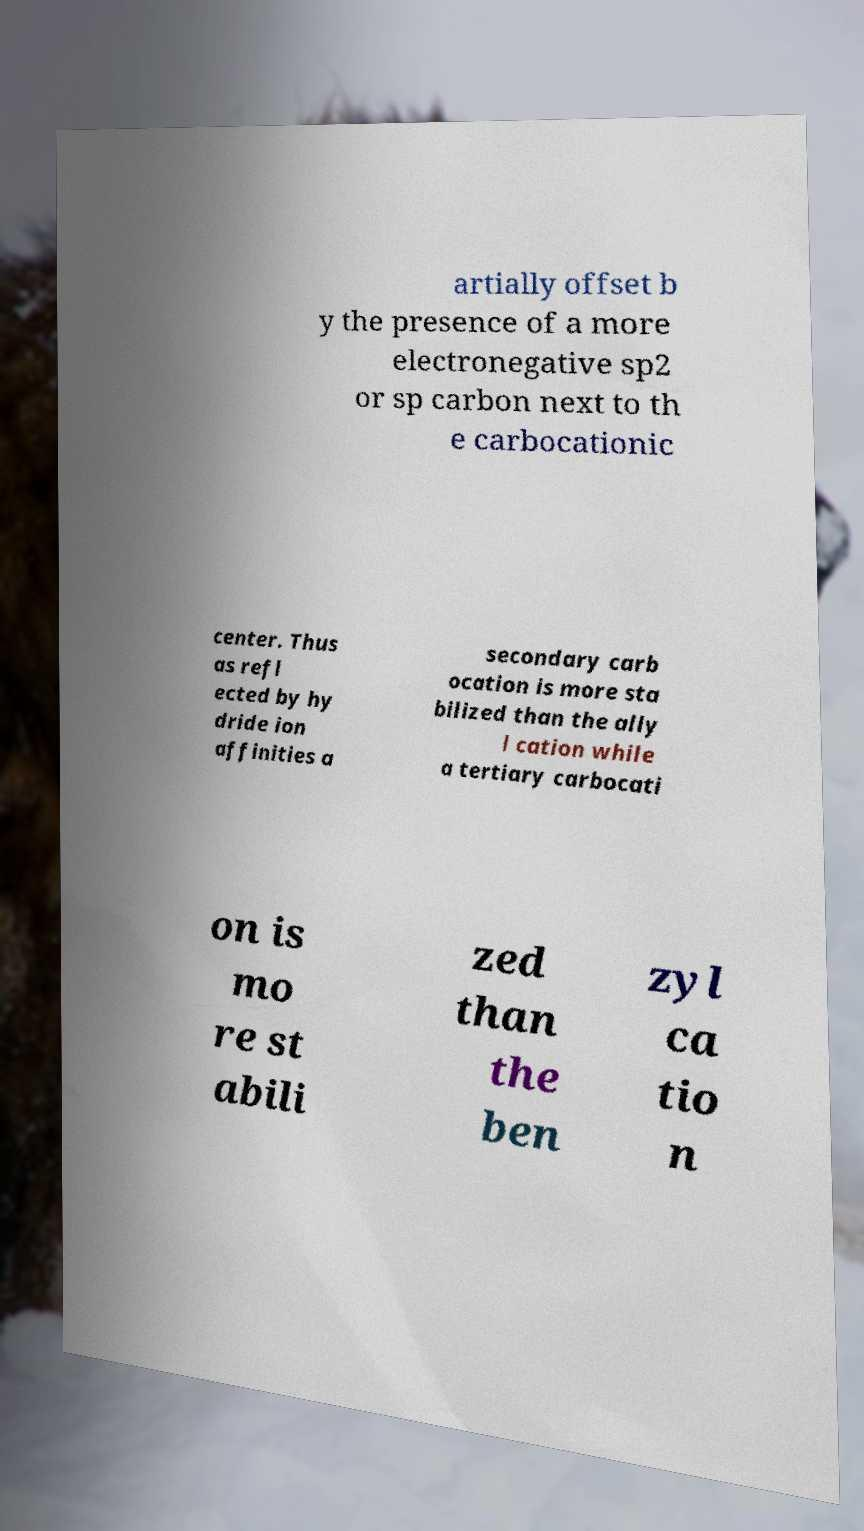There's text embedded in this image that I need extracted. Can you transcribe it verbatim? artially offset b y the presence of a more electronegative sp2 or sp carbon next to th e carbocationic center. Thus as refl ected by hy dride ion affinities a secondary carb ocation is more sta bilized than the ally l cation while a tertiary carbocati on is mo re st abili zed than the ben zyl ca tio n 